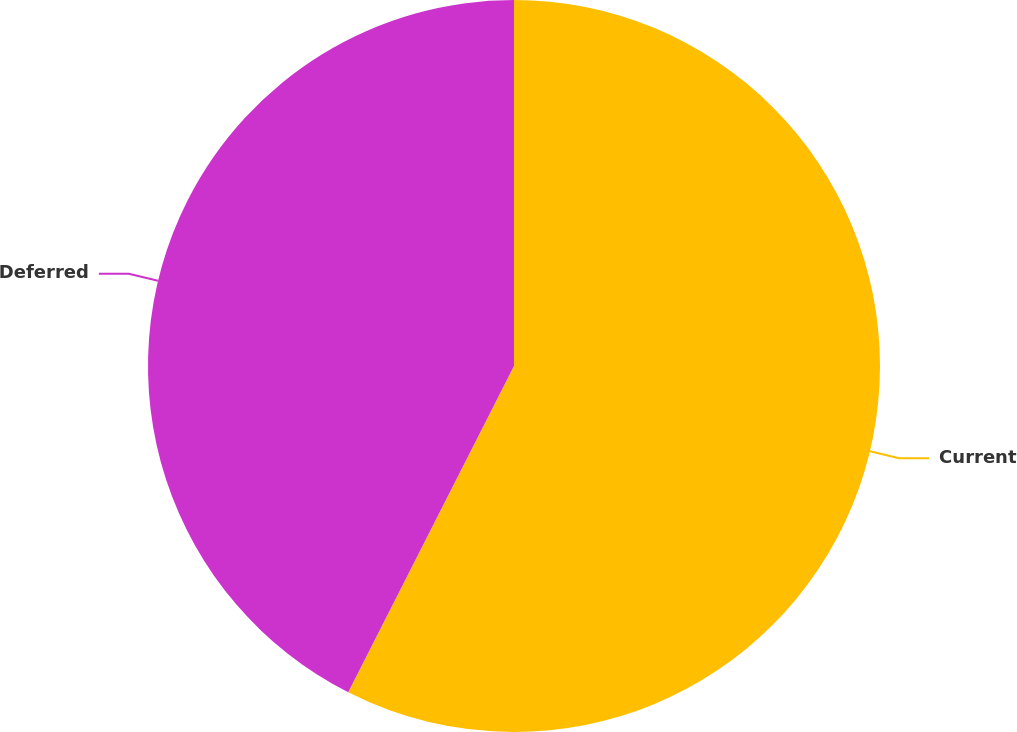<chart> <loc_0><loc_0><loc_500><loc_500><pie_chart><fcel>Current<fcel>Deferred<nl><fcel>57.48%<fcel>42.52%<nl></chart> 